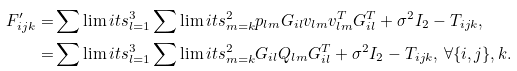<formula> <loc_0><loc_0><loc_500><loc_500>{ F } ^ { \prime } _ { i j k } = & \sum \lim i t s _ { l = 1 } ^ { 3 } \sum \lim i t s _ { m = k } ^ { 2 } p _ { l m } { G } _ { i l } { v } _ { l m } { v } ^ { T } _ { l m } { G } ^ { T } _ { i l } + \sigma ^ { 2 } { I } _ { 2 } - { T } _ { i j k } , \\ = & \sum \lim i t s _ { l = 1 } ^ { 3 } \sum \lim i t s _ { m = k } ^ { 2 } { G } _ { i l } Q _ { l m } { G } ^ { T } _ { i l } + \sigma ^ { 2 } { I } _ { 2 } - { T } _ { i j k } , \ \forall \{ i , j \} , k .</formula> 